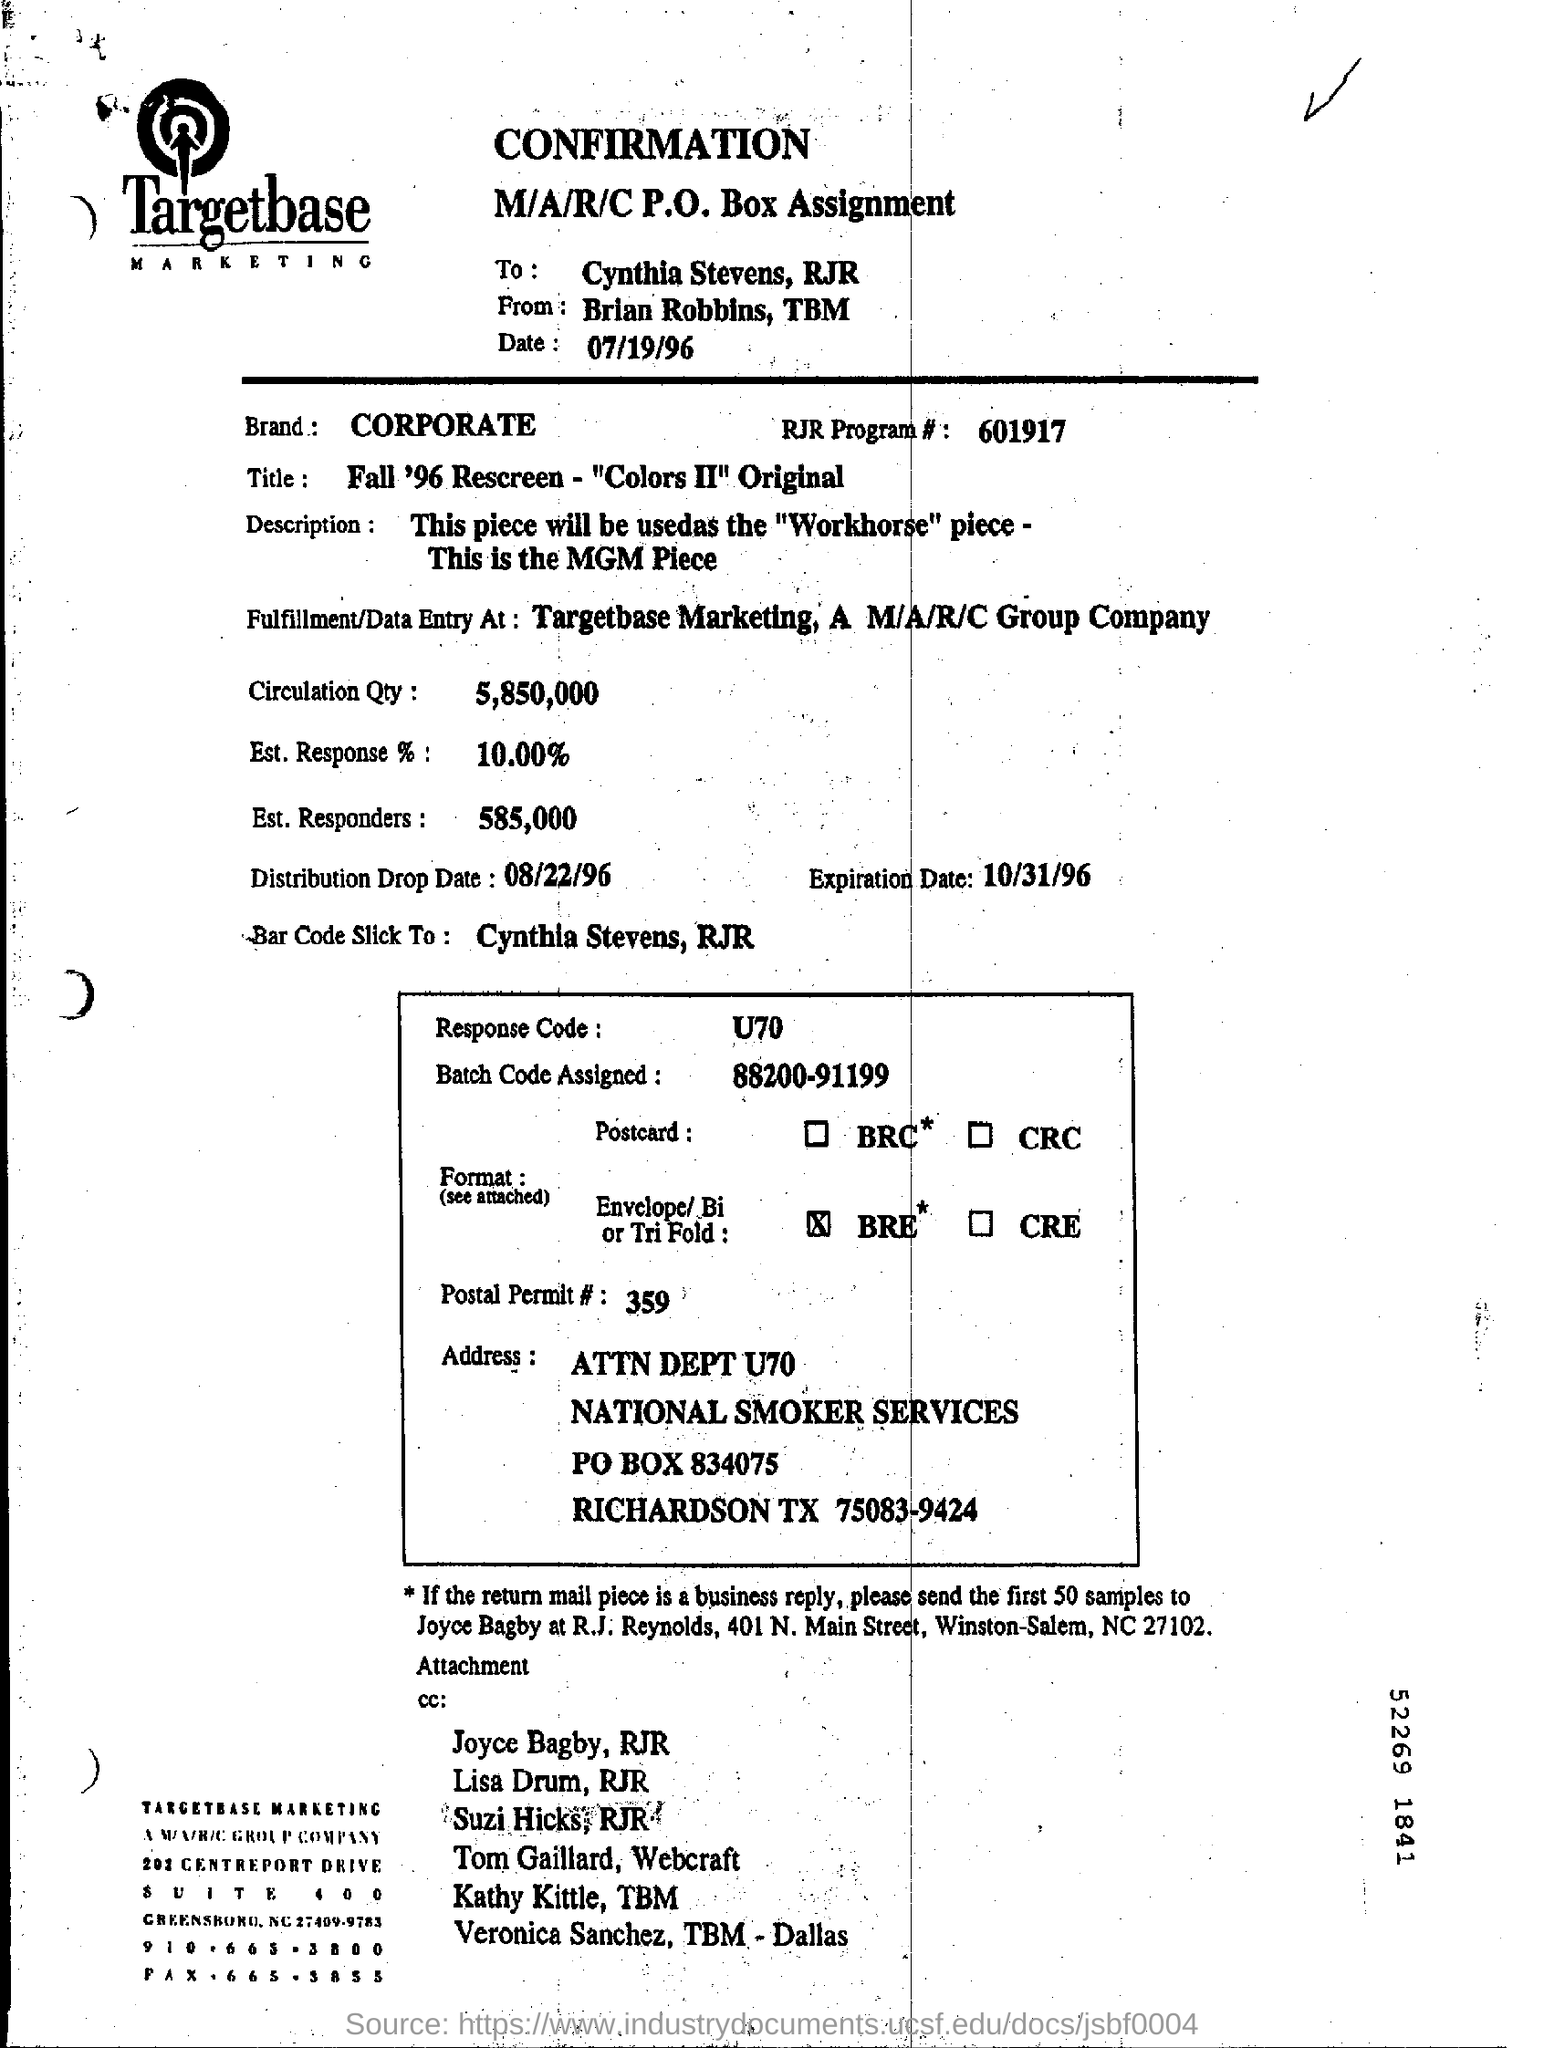Mention a couple of crucial points in this snapshot. What is the post permit number? The confirmation was dated July 19, 1996. The fulfillment or data entered is done at Targetbase Marketing, a subsidiary of A M/A/R/C Group Company. The response code is U70. Approximately 10% of estimates have been received so far. 